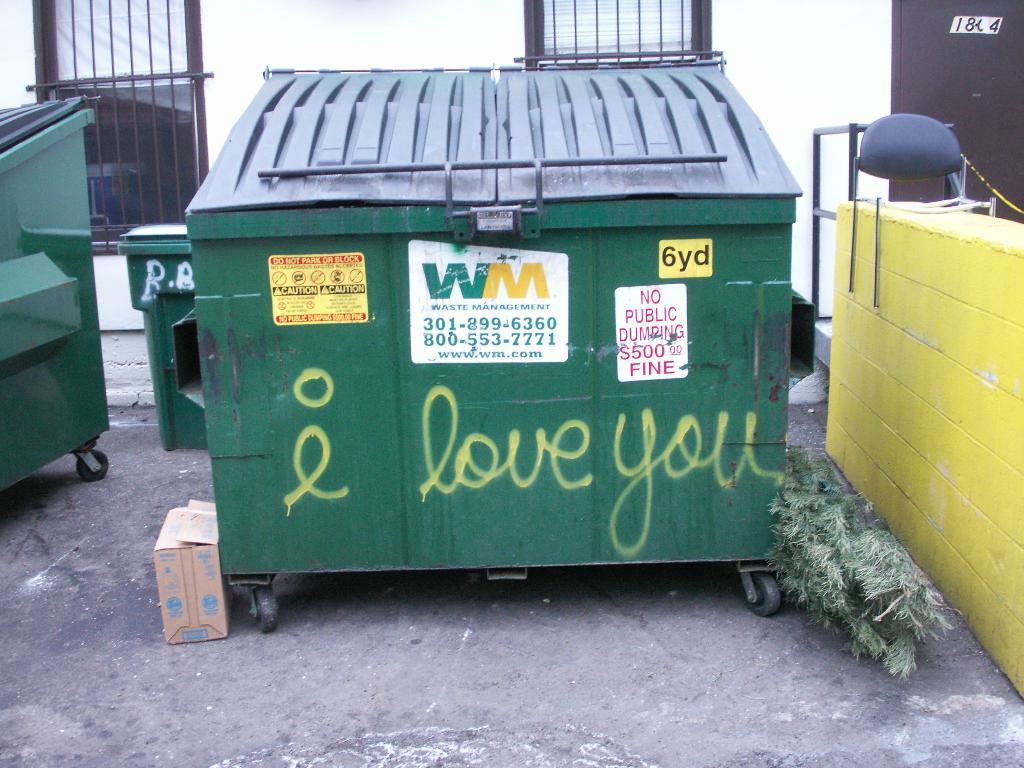<image>
Describe the image concisely. Someone has written I love you on a green dumpster. 